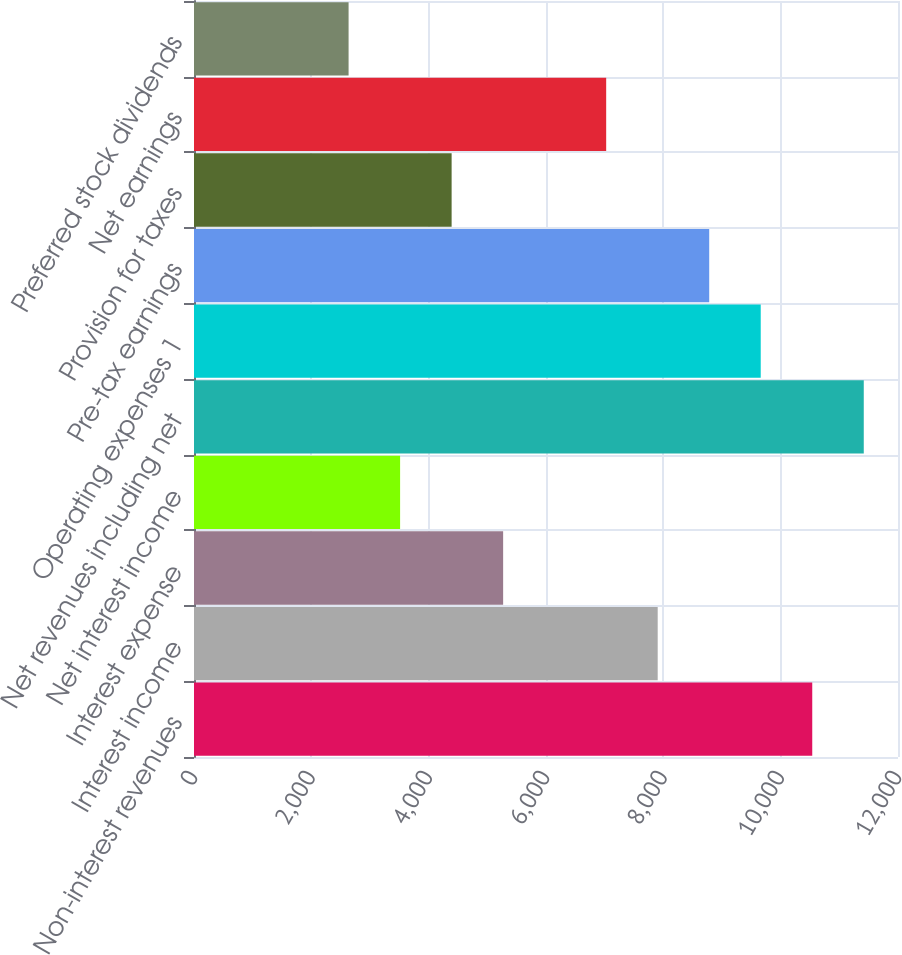Convert chart. <chart><loc_0><loc_0><loc_500><loc_500><bar_chart><fcel>Non-interest revenues<fcel>Interest income<fcel>Interest expense<fcel>Net interest income<fcel>Net revenues including net<fcel>Operating expenses 1<fcel>Pre-tax earnings<fcel>Provision for taxes<fcel>Net earnings<fcel>Preferred stock dividends<nl><fcel>10538.3<fcel>7903.88<fcel>5269.43<fcel>3513.13<fcel>11416.5<fcel>9660.17<fcel>8782.02<fcel>4391.28<fcel>7025.73<fcel>2634.99<nl></chart> 